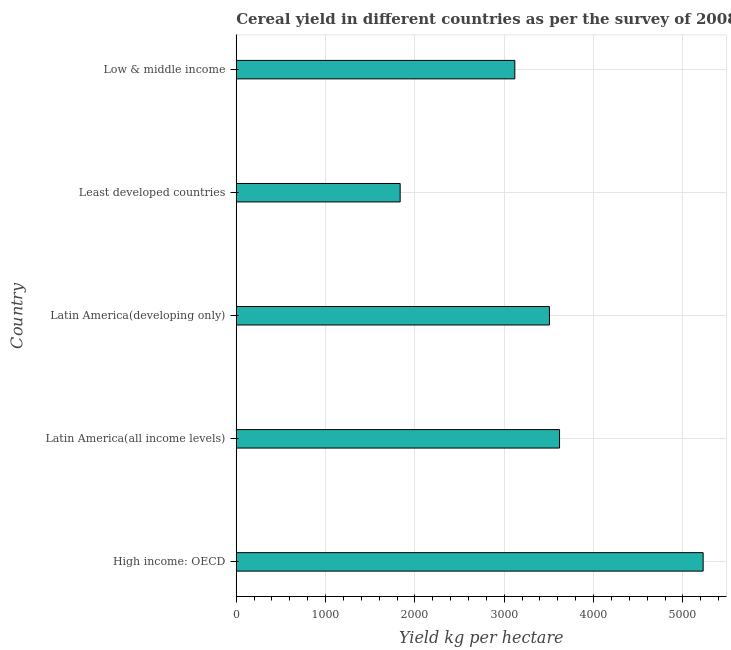What is the title of the graph?
Give a very brief answer. Cereal yield in different countries as per the survey of 2008. What is the label or title of the X-axis?
Make the answer very short. Yield kg per hectare. What is the cereal yield in Least developed countries?
Your answer should be compact. 1834.74. Across all countries, what is the maximum cereal yield?
Your response must be concise. 5226.5. Across all countries, what is the minimum cereal yield?
Your answer should be very brief. 1834.74. In which country was the cereal yield maximum?
Offer a terse response. High income: OECD. In which country was the cereal yield minimum?
Provide a short and direct response. Least developed countries. What is the sum of the cereal yield?
Provide a short and direct response. 1.73e+04. What is the difference between the cereal yield in Least developed countries and Low & middle income?
Offer a terse response. -1283.42. What is the average cereal yield per country?
Make the answer very short. 3460.87. What is the median cereal yield?
Make the answer very short. 3505.87. In how many countries, is the cereal yield greater than 2800 kg per hectare?
Ensure brevity in your answer.  4. What is the ratio of the cereal yield in High income: OECD to that in Low & middle income?
Your response must be concise. 1.68. Is the cereal yield in Least developed countries less than that in Low & middle income?
Your answer should be compact. Yes. Is the difference between the cereal yield in High income: OECD and Least developed countries greater than the difference between any two countries?
Offer a terse response. Yes. What is the difference between the highest and the second highest cereal yield?
Offer a very short reply. 1607.41. What is the difference between the highest and the lowest cereal yield?
Keep it short and to the point. 3391.76. In how many countries, is the cereal yield greater than the average cereal yield taken over all countries?
Give a very brief answer. 3. Are all the bars in the graph horizontal?
Offer a very short reply. Yes. How many countries are there in the graph?
Your response must be concise. 5. What is the difference between two consecutive major ticks on the X-axis?
Ensure brevity in your answer.  1000. Are the values on the major ticks of X-axis written in scientific E-notation?
Your response must be concise. No. What is the Yield kg per hectare of High income: OECD?
Your response must be concise. 5226.5. What is the Yield kg per hectare of Latin America(all income levels)?
Offer a very short reply. 3619.09. What is the Yield kg per hectare in Latin America(developing only)?
Offer a very short reply. 3505.87. What is the Yield kg per hectare in Least developed countries?
Provide a succinct answer. 1834.74. What is the Yield kg per hectare in Low & middle income?
Provide a succinct answer. 3118.16. What is the difference between the Yield kg per hectare in High income: OECD and Latin America(all income levels)?
Give a very brief answer. 1607.41. What is the difference between the Yield kg per hectare in High income: OECD and Latin America(developing only)?
Your answer should be very brief. 1720.63. What is the difference between the Yield kg per hectare in High income: OECD and Least developed countries?
Your response must be concise. 3391.76. What is the difference between the Yield kg per hectare in High income: OECD and Low & middle income?
Provide a short and direct response. 2108.34. What is the difference between the Yield kg per hectare in Latin America(all income levels) and Latin America(developing only)?
Your answer should be very brief. 113.22. What is the difference between the Yield kg per hectare in Latin America(all income levels) and Least developed countries?
Keep it short and to the point. 1784.35. What is the difference between the Yield kg per hectare in Latin America(all income levels) and Low & middle income?
Ensure brevity in your answer.  500.93. What is the difference between the Yield kg per hectare in Latin America(developing only) and Least developed countries?
Keep it short and to the point. 1671.13. What is the difference between the Yield kg per hectare in Latin America(developing only) and Low & middle income?
Offer a terse response. 387.71. What is the difference between the Yield kg per hectare in Least developed countries and Low & middle income?
Provide a short and direct response. -1283.42. What is the ratio of the Yield kg per hectare in High income: OECD to that in Latin America(all income levels)?
Your answer should be very brief. 1.44. What is the ratio of the Yield kg per hectare in High income: OECD to that in Latin America(developing only)?
Provide a succinct answer. 1.49. What is the ratio of the Yield kg per hectare in High income: OECD to that in Least developed countries?
Your answer should be very brief. 2.85. What is the ratio of the Yield kg per hectare in High income: OECD to that in Low & middle income?
Offer a terse response. 1.68. What is the ratio of the Yield kg per hectare in Latin America(all income levels) to that in Latin America(developing only)?
Provide a short and direct response. 1.03. What is the ratio of the Yield kg per hectare in Latin America(all income levels) to that in Least developed countries?
Ensure brevity in your answer.  1.97. What is the ratio of the Yield kg per hectare in Latin America(all income levels) to that in Low & middle income?
Offer a very short reply. 1.16. What is the ratio of the Yield kg per hectare in Latin America(developing only) to that in Least developed countries?
Provide a short and direct response. 1.91. What is the ratio of the Yield kg per hectare in Latin America(developing only) to that in Low & middle income?
Offer a very short reply. 1.12. What is the ratio of the Yield kg per hectare in Least developed countries to that in Low & middle income?
Offer a very short reply. 0.59. 